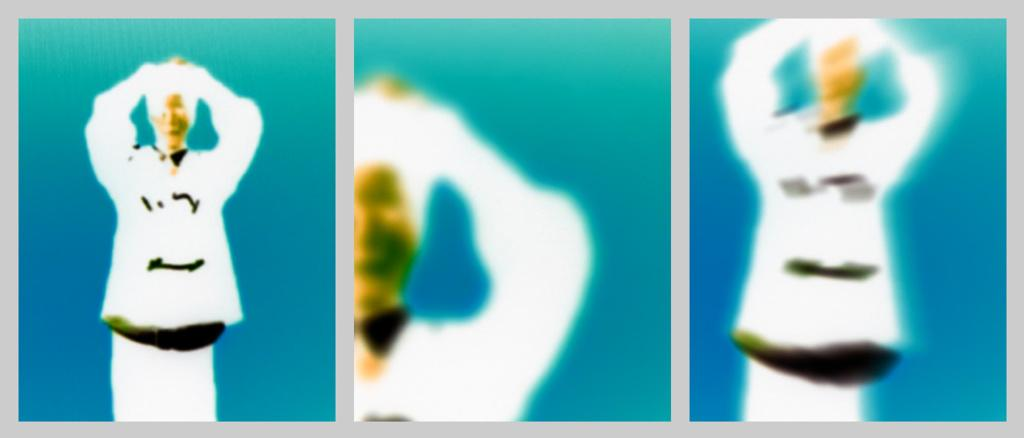What type of image is being described? The image is a collage. Can you identify any subjects in the image? Yes, there is a person standing in the image. How would you describe the quality of the image? The image is blurry. What type of sack is being carried by the person in the image? There is no sack visible in the image; only a person standing is mentioned. 